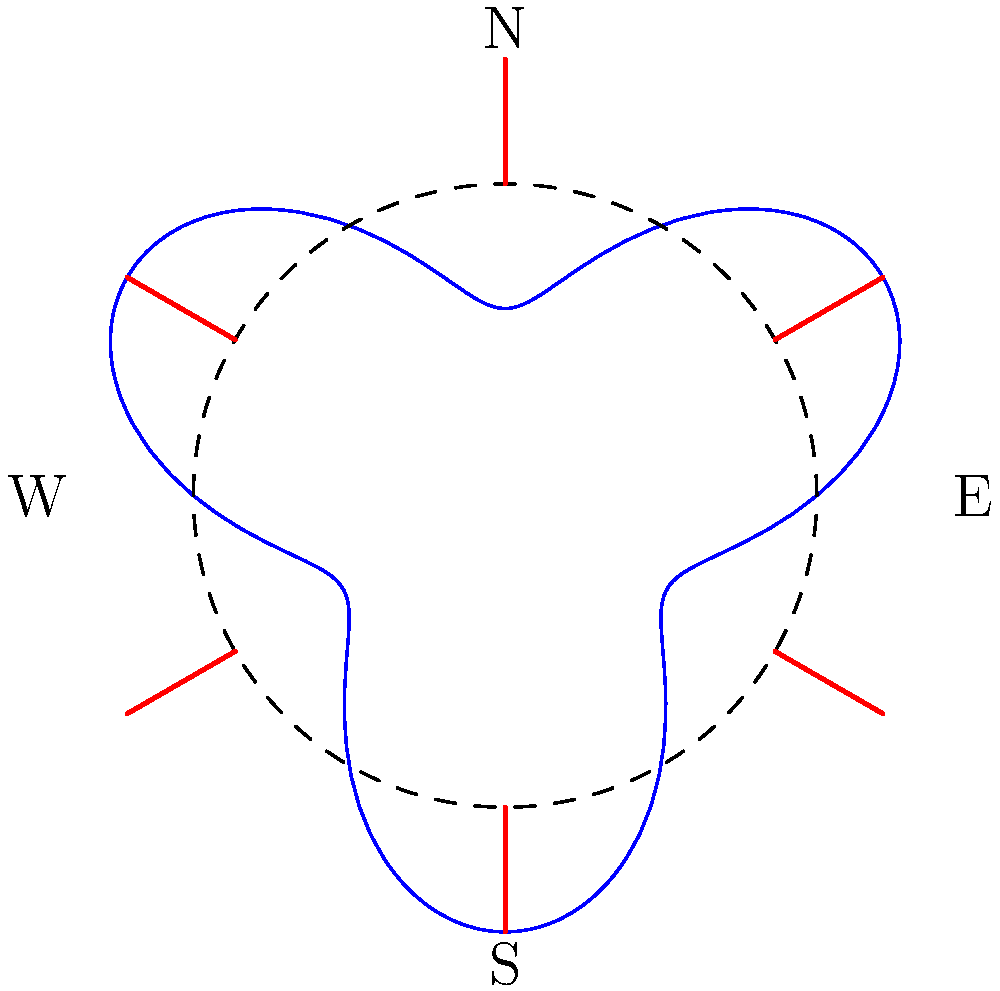In our futuristic dome-shaped building design, we've modeled the optimal placement of solar panels using the polar function $r(\theta) = 5 + 2\sin(3\theta)$, where $r$ is in meters. The base radius of the dome is 5 meters. What is the maximum radial distance from the center where solar panels should be placed, and at which angles (in degrees) does this occur? To solve this problem, we need to follow these steps:

1) The function $r(\theta) = 5 + 2\sin(3\theta)$ represents the radial distance from the center of the dome to the solar panel placement at any given angle $\theta$.

2) To find the maximum radial distance, we need to find the maximum value of this function.

3) The maximum value of sine is 1, which occurs when its argument is $\frac{\pi}{2}$ or 90°.

4) In our function, the argument of sine is $3\theta$. So, we need to solve:

   $3\theta = \frac{\pi}{2} + 2\pi n$, where $n$ is an integer.

5) Solving for $\theta$:

   $\theta = \frac{\pi}{6} + \frac{2\pi n}{3}$

6) This gives us the angles where the maximum occurs. In the range $[0, 2\pi]$, this happens at:

   $\theta = \frac{\pi}{6}, \frac{5\pi}{6}, \frac{3\pi}{2}$

7) Converting to degrees:

   $\theta = 30°, 150°, 270°$

8) At these angles, the radial distance is:

   $r = 5 + 2\sin(3\theta) = 5 + 2(1) = 7$ meters

Therefore, the maximum radial distance is 7 meters, occurring at angles 30°, 150°, and 270°.
Answer: 7 meters; 30°, 150°, 270° 